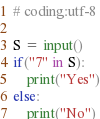Convert code to text. <code><loc_0><loc_0><loc_500><loc_500><_Python_># coding:utf-8

S = input()
if("7" in S):
	print("Yes")
else:
  	print("No")</code> 